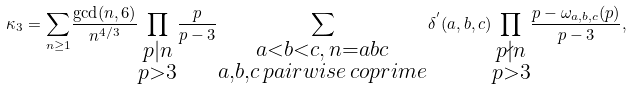Convert formula to latex. <formula><loc_0><loc_0><loc_500><loc_500>\kappa _ { 3 } = { \sum _ { n \geq 1 } } { \frac { \gcd ( n , 6 ) } { n ^ { 4 / 3 } } } { \prod _ { \substack { { p | n } \\ { p > 3 } } } } { \frac { p } { p - 3 } } { \sum _ { \substack { { a < b < c , \, n = a b c } \\ { a , b , c \, p a i r w i s e \, c o p r i m e } } } } { \delta ^ { ^ { \prime } } ( a , b , c ) } { \prod _ { \substack { { p \nmid n } \\ p > 3 } } } { \frac { p - { \omega _ { a , b , c } { ( p ) } } } { p - 3 } } ,</formula> 